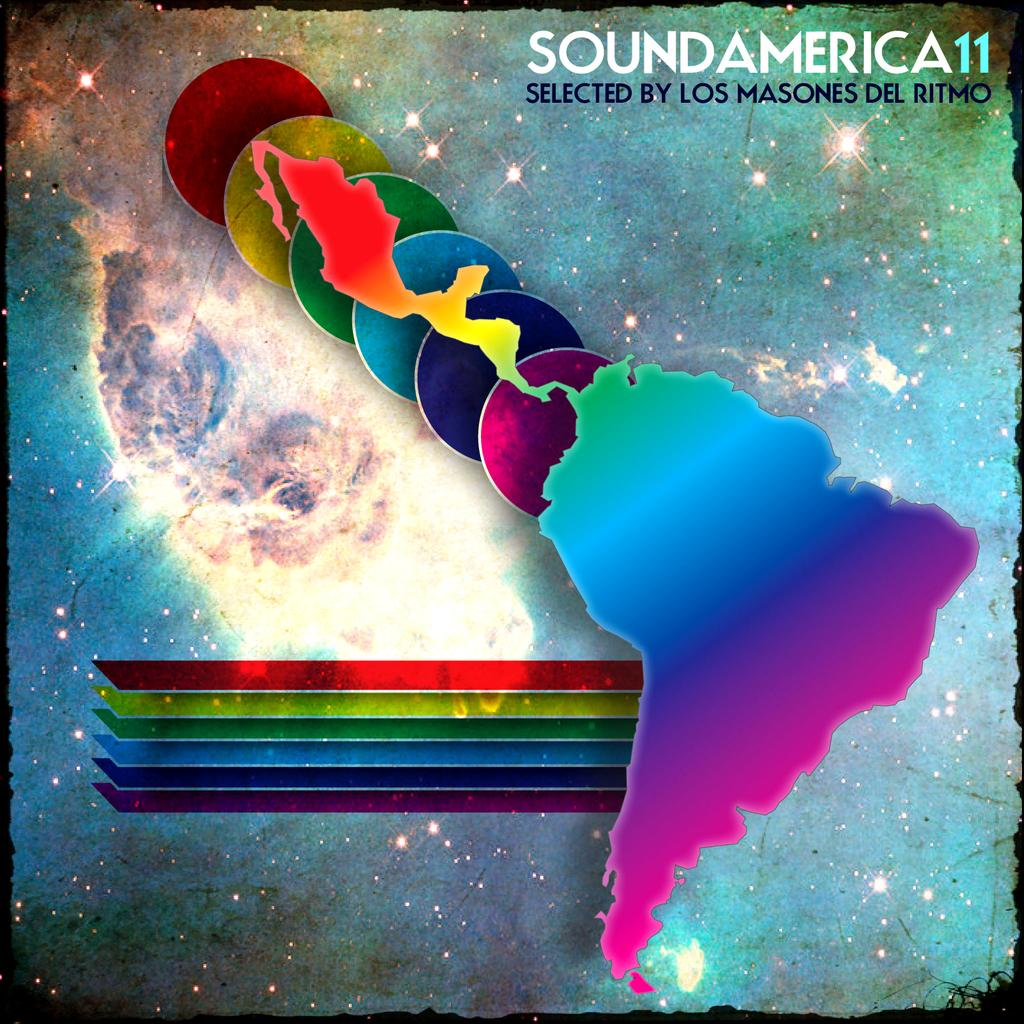<image>
Describe the image concisely. An album cover with the Milky Way and countries on it for Sound America11 